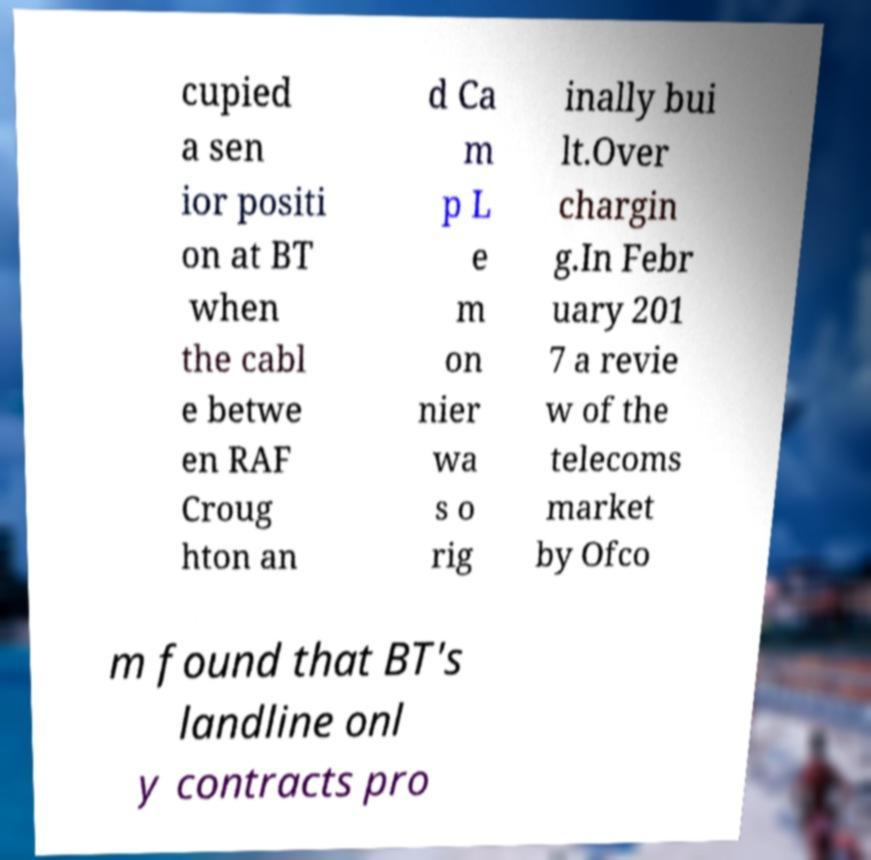Please read and relay the text visible in this image. What does it say? cupied a sen ior positi on at BT when the cabl e betwe en RAF Croug hton an d Ca m p L e m on nier wa s o rig inally bui lt.Over chargin g.In Febr uary 201 7 a revie w of the telecoms market by Ofco m found that BT's landline onl y contracts pro 